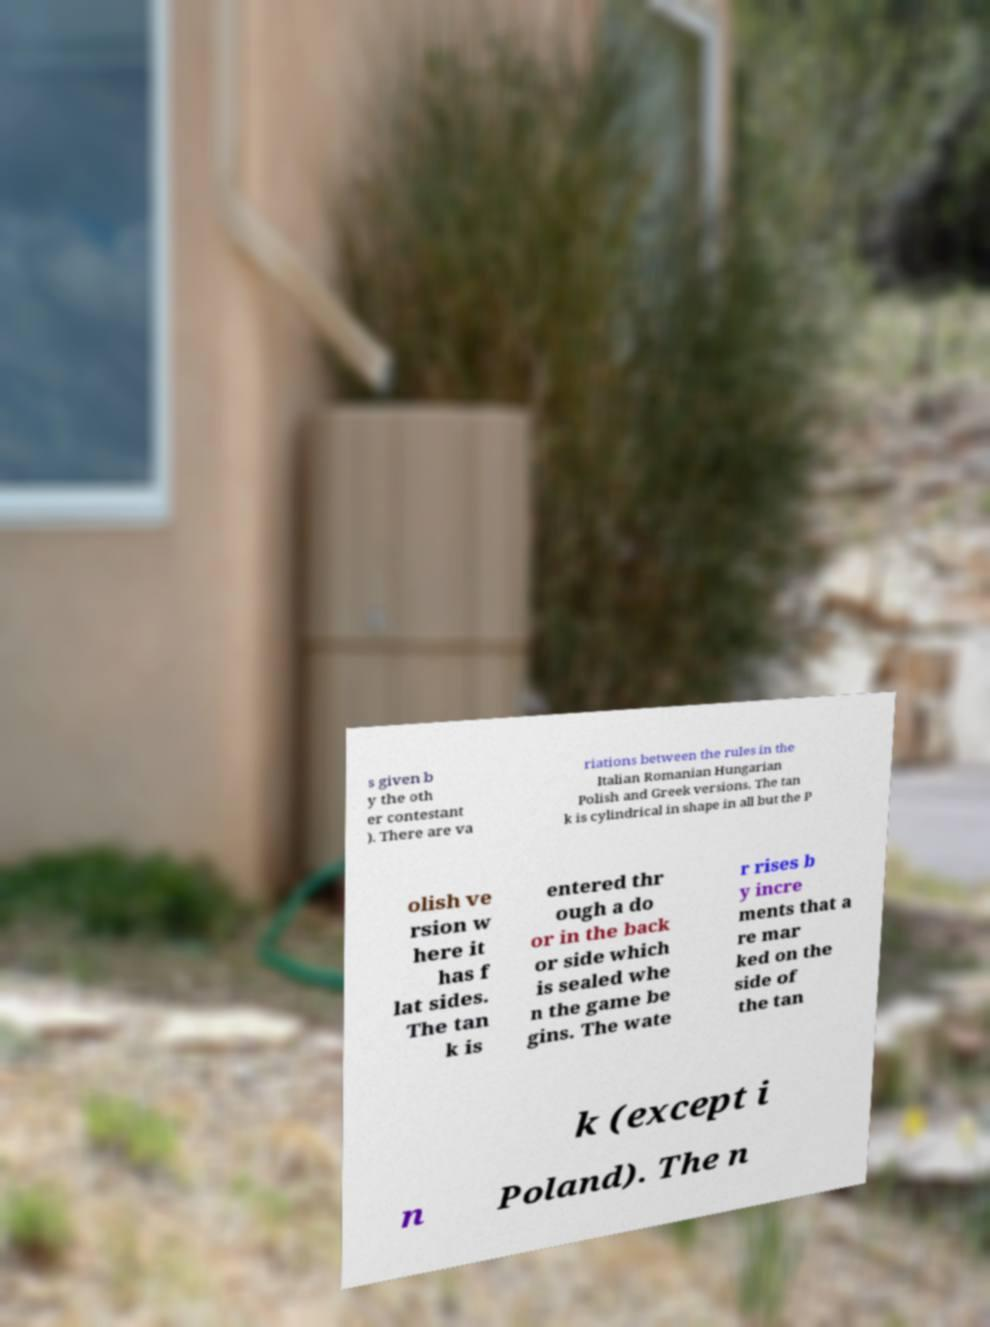There's text embedded in this image that I need extracted. Can you transcribe it verbatim? s given b y the oth er contestant ). There are va riations between the rules in the Italian Romanian Hungarian Polish and Greek versions. The tan k is cylindrical in shape in all but the P olish ve rsion w here it has f lat sides. The tan k is entered thr ough a do or in the back or side which is sealed whe n the game be gins. The wate r rises b y incre ments that a re mar ked on the side of the tan k (except i n Poland). The n 